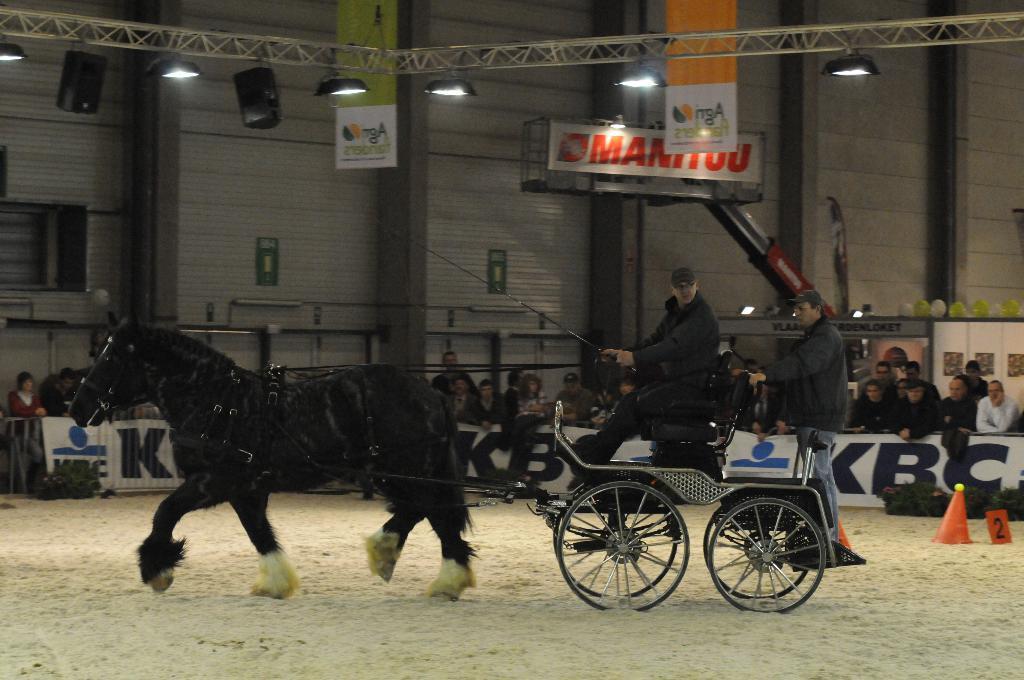In one or two sentences, can you explain what this image depicts? In this image I can see a horse and a cart. Here on this card I can see two men and I can see one is standing and one is sitting. I can also see one of them is holding a stick and ropes. In background I can see boards, few orange colour cones and I can see number of people are standing. On these words I can see something is written and here I can see few lights. 